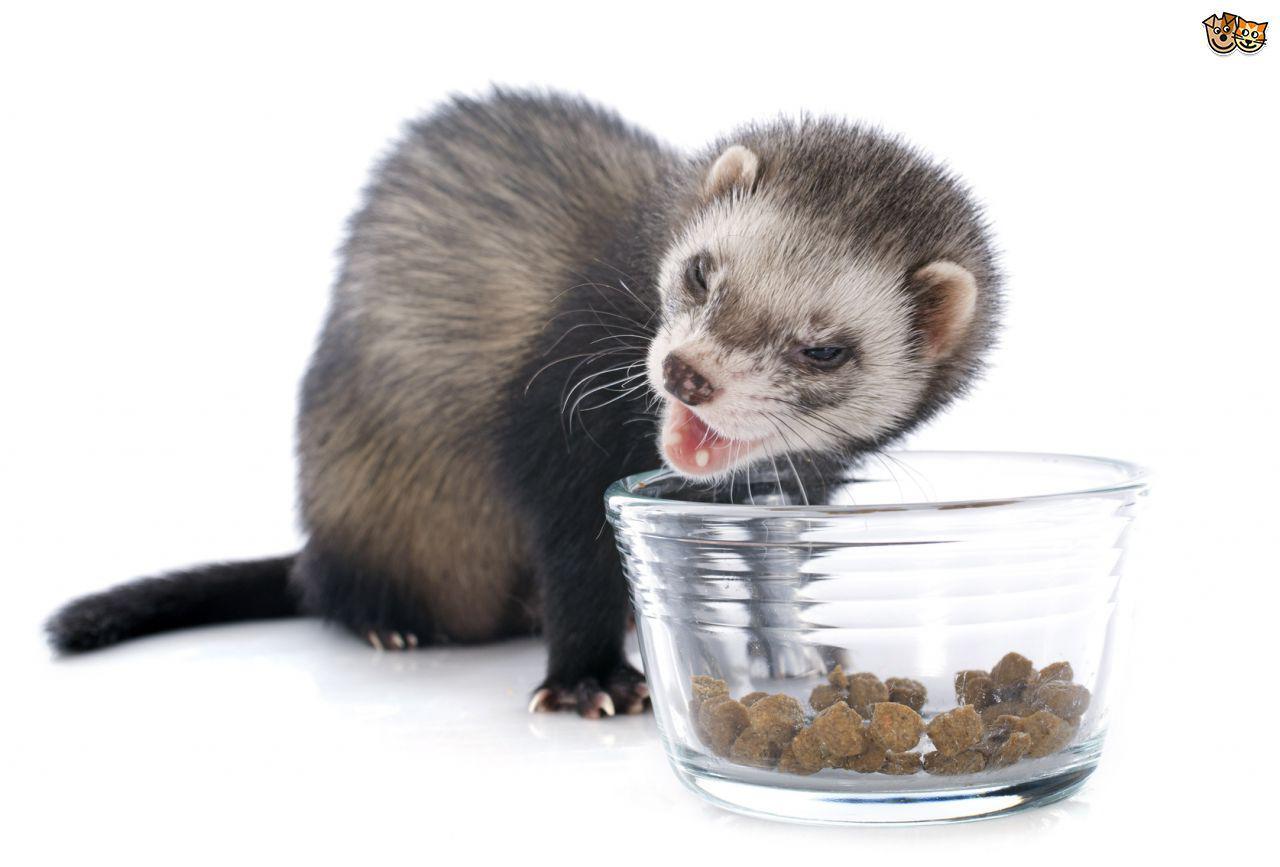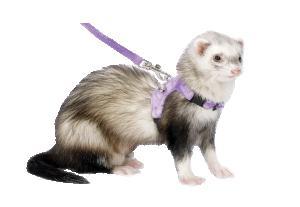The first image is the image on the left, the second image is the image on the right. Analyze the images presented: Is the assertion "One image shows a ferret standing behind a bowl of food, with its tail extending to the left and its head turned leftward." valid? Answer yes or no. Yes. The first image is the image on the left, the second image is the image on the right. For the images displayed, is the sentence "A ferret is eating out of a dish." factually correct? Answer yes or no. Yes. 